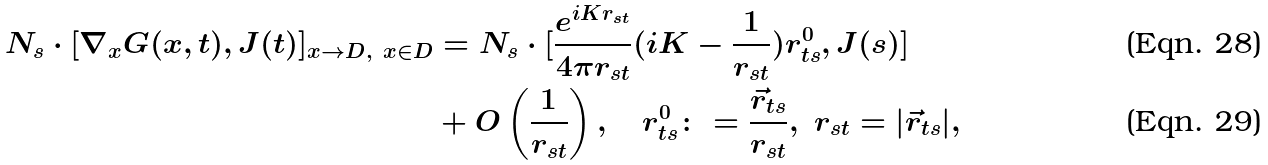<formula> <loc_0><loc_0><loc_500><loc_500>N _ { s } \cdot [ \nabla _ { x } G ( x , t ) , J ( t ) ] _ { x \to D , \ x \in D } & = N _ { s } \cdot [ \frac { e ^ { i K r _ { s t } } } { 4 \pi r _ { s t } } ( i K - \frac { 1 } { r _ { s t } } ) r ^ { 0 } _ { t s } , J ( s ) ] \\ & + O \left ( \frac { 1 } { r _ { s t } } \right ) , \quad r ^ { 0 } _ { t s } \colon = \frac { \vec { r } _ { t s } } { r _ { s t } } , \ r _ { s t } = | \vec { r } _ { t s } | ,</formula> 